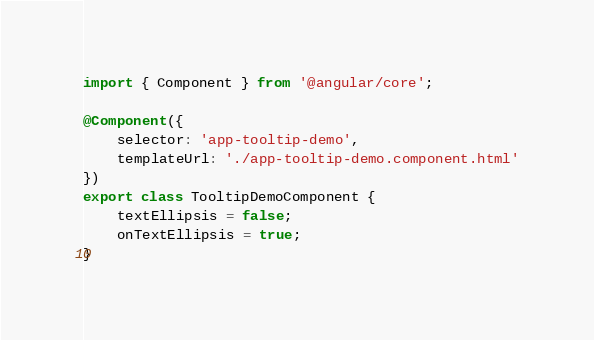Convert code to text. <code><loc_0><loc_0><loc_500><loc_500><_TypeScript_>import { Component } from '@angular/core';

@Component({
	selector: 'app-tooltip-demo',
	templateUrl: './app-tooltip-demo.component.html'
})
export class TooltipDemoComponent {
	textEllipsis = false;
	onTextEllipsis = true;
}
</code> 